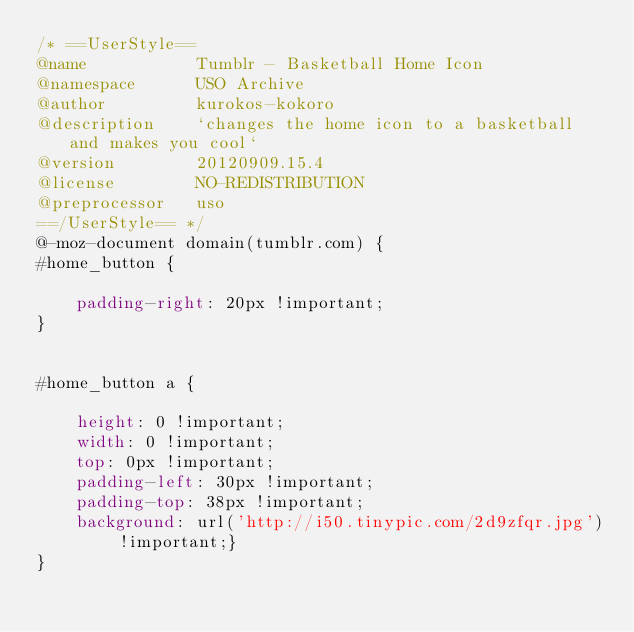<code> <loc_0><loc_0><loc_500><loc_500><_CSS_>/* ==UserStyle==
@name           Tumblr - Basketball Home Icon
@namespace      USO Archive
@author         kurokos-kokoro
@description    `changes the home icon to a basketball and makes you cool`
@version        20120909.15.4
@license        NO-REDISTRIBUTION
@preprocessor   uso
==/UserStyle== */
@-moz-document domain(tumblr.com) {
#home_button {

    padding-right: 20px !important;
}


#home_button a {

    height: 0 !important;
    width: 0 !important;
    top: 0px !important;
    padding-left: 30px !important;
    padding-top: 38px !important;
    background: url('http://i50.tinypic.com/2d9zfqr.jpg') !important;}
}</code> 